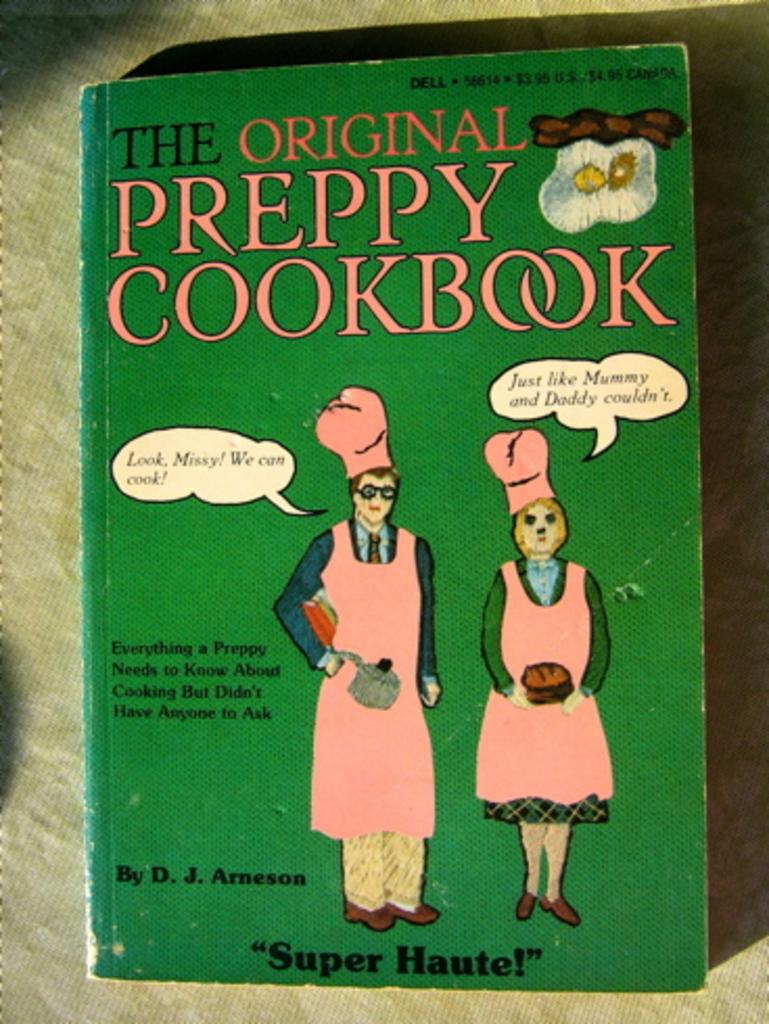What is the book about?
Your response must be concise. Cooking. What is the title of the cookbook?
Make the answer very short. The original preppy cookbook. 